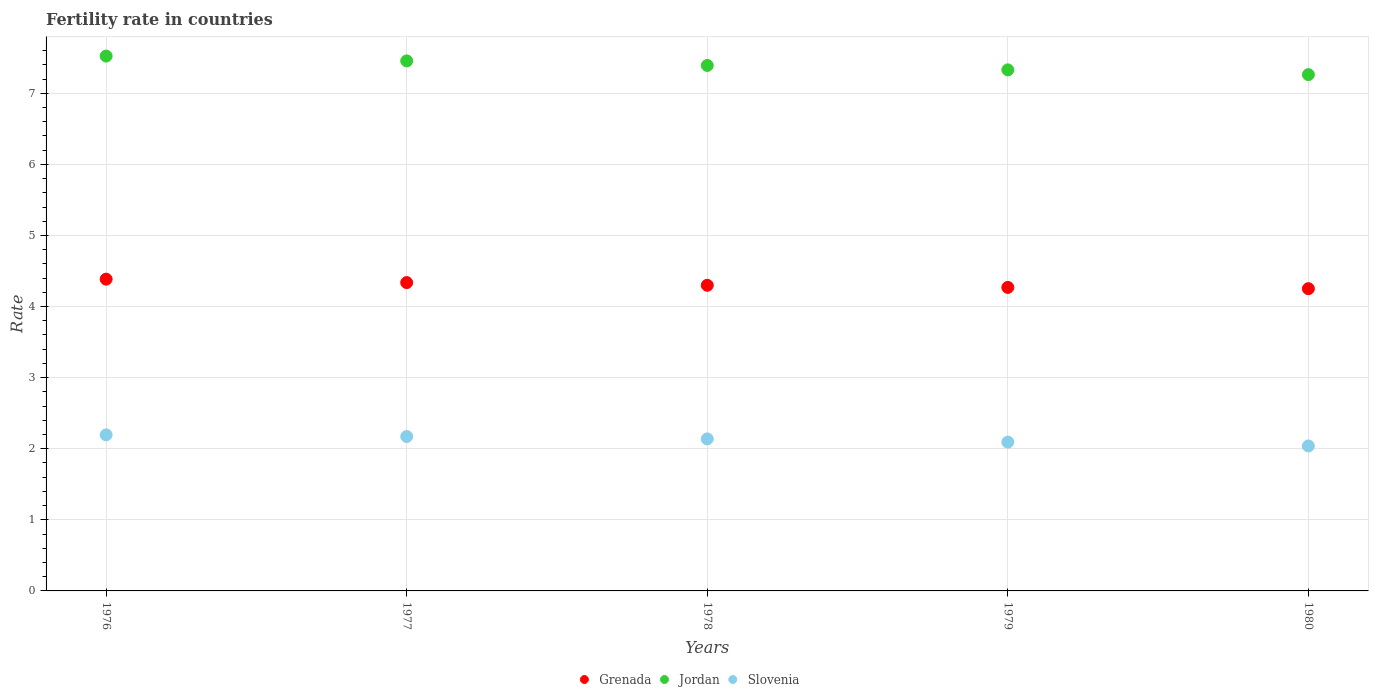How many different coloured dotlines are there?
Provide a succinct answer. 3. Is the number of dotlines equal to the number of legend labels?
Keep it short and to the point. Yes. What is the fertility rate in Grenada in 1977?
Your answer should be compact. 4.34. Across all years, what is the maximum fertility rate in Jordan?
Your answer should be very brief. 7.52. Across all years, what is the minimum fertility rate in Slovenia?
Offer a terse response. 2.04. In which year was the fertility rate in Grenada maximum?
Provide a short and direct response. 1976. In which year was the fertility rate in Grenada minimum?
Offer a terse response. 1980. What is the total fertility rate in Jordan in the graph?
Keep it short and to the point. 36.96. What is the difference between the fertility rate in Grenada in 1977 and that in 1980?
Your answer should be compact. 0.09. What is the difference between the fertility rate in Jordan in 1978 and the fertility rate in Slovenia in 1976?
Offer a terse response. 5.2. What is the average fertility rate in Jordan per year?
Provide a succinct answer. 7.39. In the year 1976, what is the difference between the fertility rate in Slovenia and fertility rate in Grenada?
Provide a short and direct response. -2.19. In how many years, is the fertility rate in Slovenia greater than 5?
Provide a succinct answer. 0. What is the ratio of the fertility rate in Slovenia in 1977 to that in 1980?
Provide a short and direct response. 1.07. Is the fertility rate in Jordan in 1979 less than that in 1980?
Your answer should be very brief. No. What is the difference between the highest and the second highest fertility rate in Grenada?
Your answer should be very brief. 0.05. What is the difference between the highest and the lowest fertility rate in Grenada?
Your answer should be compact. 0.13. In how many years, is the fertility rate in Slovenia greater than the average fertility rate in Slovenia taken over all years?
Offer a terse response. 3. Is it the case that in every year, the sum of the fertility rate in Jordan and fertility rate in Grenada  is greater than the fertility rate in Slovenia?
Your response must be concise. Yes. Is the fertility rate in Jordan strictly less than the fertility rate in Slovenia over the years?
Offer a very short reply. No. How many dotlines are there?
Provide a short and direct response. 3. What is the difference between two consecutive major ticks on the Y-axis?
Provide a short and direct response. 1. Does the graph contain any zero values?
Your answer should be very brief. No. Does the graph contain grids?
Keep it short and to the point. Yes. How are the legend labels stacked?
Provide a succinct answer. Horizontal. What is the title of the graph?
Your answer should be very brief. Fertility rate in countries. What is the label or title of the X-axis?
Your answer should be very brief. Years. What is the label or title of the Y-axis?
Offer a very short reply. Rate. What is the Rate of Grenada in 1976?
Your answer should be compact. 4.38. What is the Rate in Jordan in 1976?
Keep it short and to the point. 7.52. What is the Rate of Slovenia in 1976?
Your answer should be very brief. 2.19. What is the Rate in Grenada in 1977?
Ensure brevity in your answer.  4.34. What is the Rate of Jordan in 1977?
Ensure brevity in your answer.  7.46. What is the Rate in Slovenia in 1977?
Make the answer very short. 2.17. What is the Rate in Grenada in 1978?
Provide a short and direct response. 4.3. What is the Rate of Jordan in 1978?
Keep it short and to the point. 7.39. What is the Rate in Slovenia in 1978?
Your answer should be compact. 2.14. What is the Rate of Grenada in 1979?
Offer a very short reply. 4.27. What is the Rate of Jordan in 1979?
Give a very brief answer. 7.33. What is the Rate in Slovenia in 1979?
Offer a terse response. 2.09. What is the Rate in Grenada in 1980?
Your answer should be very brief. 4.25. What is the Rate in Jordan in 1980?
Give a very brief answer. 7.26. What is the Rate of Slovenia in 1980?
Keep it short and to the point. 2.04. Across all years, what is the maximum Rate of Grenada?
Your answer should be very brief. 4.38. Across all years, what is the maximum Rate in Jordan?
Make the answer very short. 7.52. Across all years, what is the maximum Rate in Slovenia?
Provide a short and direct response. 2.19. Across all years, what is the minimum Rate of Grenada?
Provide a succinct answer. 4.25. Across all years, what is the minimum Rate of Jordan?
Your answer should be very brief. 7.26. Across all years, what is the minimum Rate in Slovenia?
Your answer should be very brief. 2.04. What is the total Rate of Grenada in the graph?
Your answer should be compact. 21.54. What is the total Rate in Jordan in the graph?
Ensure brevity in your answer.  36.96. What is the total Rate in Slovenia in the graph?
Your response must be concise. 10.64. What is the difference between the Rate of Grenada in 1976 and that in 1977?
Provide a short and direct response. 0.05. What is the difference between the Rate in Jordan in 1976 and that in 1977?
Your answer should be compact. 0.07. What is the difference between the Rate of Slovenia in 1976 and that in 1977?
Your answer should be very brief. 0.02. What is the difference between the Rate in Grenada in 1976 and that in 1978?
Your answer should be very brief. 0.09. What is the difference between the Rate of Jordan in 1976 and that in 1978?
Give a very brief answer. 0.13. What is the difference between the Rate in Slovenia in 1976 and that in 1978?
Ensure brevity in your answer.  0.06. What is the difference between the Rate in Grenada in 1976 and that in 1979?
Your answer should be compact. 0.12. What is the difference between the Rate of Jordan in 1976 and that in 1979?
Offer a terse response. 0.19. What is the difference between the Rate in Slovenia in 1976 and that in 1979?
Keep it short and to the point. 0.1. What is the difference between the Rate of Grenada in 1976 and that in 1980?
Ensure brevity in your answer.  0.13. What is the difference between the Rate of Jordan in 1976 and that in 1980?
Give a very brief answer. 0.26. What is the difference between the Rate of Slovenia in 1976 and that in 1980?
Provide a succinct answer. 0.16. What is the difference between the Rate of Grenada in 1977 and that in 1978?
Your answer should be compact. 0.04. What is the difference between the Rate of Jordan in 1977 and that in 1978?
Ensure brevity in your answer.  0.06. What is the difference between the Rate in Slovenia in 1977 and that in 1978?
Your answer should be compact. 0.03. What is the difference between the Rate in Grenada in 1977 and that in 1979?
Ensure brevity in your answer.  0.07. What is the difference between the Rate of Jordan in 1977 and that in 1979?
Give a very brief answer. 0.13. What is the difference between the Rate of Slovenia in 1977 and that in 1979?
Ensure brevity in your answer.  0.08. What is the difference between the Rate of Grenada in 1977 and that in 1980?
Provide a succinct answer. 0.09. What is the difference between the Rate in Jordan in 1977 and that in 1980?
Your answer should be very brief. 0.19. What is the difference between the Rate of Slovenia in 1977 and that in 1980?
Offer a terse response. 0.13. What is the difference between the Rate in Jordan in 1978 and that in 1979?
Provide a succinct answer. 0.06. What is the difference between the Rate of Slovenia in 1978 and that in 1979?
Provide a short and direct response. 0.04. What is the difference between the Rate of Grenada in 1978 and that in 1980?
Ensure brevity in your answer.  0.05. What is the difference between the Rate in Jordan in 1978 and that in 1980?
Give a very brief answer. 0.13. What is the difference between the Rate of Slovenia in 1978 and that in 1980?
Keep it short and to the point. 0.1. What is the difference between the Rate in Grenada in 1979 and that in 1980?
Provide a short and direct response. 0.02. What is the difference between the Rate in Jordan in 1979 and that in 1980?
Offer a very short reply. 0.07. What is the difference between the Rate in Slovenia in 1979 and that in 1980?
Provide a succinct answer. 0.05. What is the difference between the Rate of Grenada in 1976 and the Rate of Jordan in 1977?
Your response must be concise. -3.07. What is the difference between the Rate of Grenada in 1976 and the Rate of Slovenia in 1977?
Make the answer very short. 2.21. What is the difference between the Rate of Jordan in 1976 and the Rate of Slovenia in 1977?
Offer a very short reply. 5.35. What is the difference between the Rate in Grenada in 1976 and the Rate in Jordan in 1978?
Give a very brief answer. -3.01. What is the difference between the Rate of Grenada in 1976 and the Rate of Slovenia in 1978?
Offer a very short reply. 2.25. What is the difference between the Rate in Jordan in 1976 and the Rate in Slovenia in 1978?
Offer a very short reply. 5.38. What is the difference between the Rate of Grenada in 1976 and the Rate of Jordan in 1979?
Your answer should be very brief. -2.94. What is the difference between the Rate of Grenada in 1976 and the Rate of Slovenia in 1979?
Keep it short and to the point. 2.29. What is the difference between the Rate in Jordan in 1976 and the Rate in Slovenia in 1979?
Give a very brief answer. 5.43. What is the difference between the Rate in Grenada in 1976 and the Rate in Jordan in 1980?
Your response must be concise. -2.88. What is the difference between the Rate in Grenada in 1976 and the Rate in Slovenia in 1980?
Give a very brief answer. 2.35. What is the difference between the Rate of Jordan in 1976 and the Rate of Slovenia in 1980?
Give a very brief answer. 5.48. What is the difference between the Rate of Grenada in 1977 and the Rate of Jordan in 1978?
Give a very brief answer. -3.05. What is the difference between the Rate in Grenada in 1977 and the Rate in Slovenia in 1978?
Make the answer very short. 2.2. What is the difference between the Rate in Jordan in 1977 and the Rate in Slovenia in 1978?
Offer a very short reply. 5.32. What is the difference between the Rate in Grenada in 1977 and the Rate in Jordan in 1979?
Give a very brief answer. -2.99. What is the difference between the Rate in Grenada in 1977 and the Rate in Slovenia in 1979?
Provide a short and direct response. 2.24. What is the difference between the Rate in Jordan in 1977 and the Rate in Slovenia in 1979?
Your answer should be very brief. 5.36. What is the difference between the Rate in Grenada in 1977 and the Rate in Jordan in 1980?
Your answer should be very brief. -2.92. What is the difference between the Rate of Grenada in 1977 and the Rate of Slovenia in 1980?
Provide a short and direct response. 2.3. What is the difference between the Rate in Jordan in 1977 and the Rate in Slovenia in 1980?
Offer a very short reply. 5.42. What is the difference between the Rate in Grenada in 1978 and the Rate in Jordan in 1979?
Your response must be concise. -3.03. What is the difference between the Rate in Grenada in 1978 and the Rate in Slovenia in 1979?
Your answer should be very brief. 2.21. What is the difference between the Rate in Jordan in 1978 and the Rate in Slovenia in 1979?
Ensure brevity in your answer.  5.3. What is the difference between the Rate of Grenada in 1978 and the Rate of Jordan in 1980?
Your answer should be very brief. -2.96. What is the difference between the Rate of Grenada in 1978 and the Rate of Slovenia in 1980?
Keep it short and to the point. 2.26. What is the difference between the Rate in Jordan in 1978 and the Rate in Slovenia in 1980?
Keep it short and to the point. 5.35. What is the difference between the Rate in Grenada in 1979 and the Rate in Jordan in 1980?
Give a very brief answer. -2.99. What is the difference between the Rate of Grenada in 1979 and the Rate of Slovenia in 1980?
Keep it short and to the point. 2.23. What is the difference between the Rate of Jordan in 1979 and the Rate of Slovenia in 1980?
Provide a short and direct response. 5.29. What is the average Rate in Grenada per year?
Your answer should be compact. 4.31. What is the average Rate in Jordan per year?
Offer a terse response. 7.39. What is the average Rate of Slovenia per year?
Your answer should be compact. 2.13. In the year 1976, what is the difference between the Rate of Grenada and Rate of Jordan?
Make the answer very short. -3.14. In the year 1976, what is the difference between the Rate of Grenada and Rate of Slovenia?
Your answer should be very brief. 2.19. In the year 1976, what is the difference between the Rate in Jordan and Rate in Slovenia?
Make the answer very short. 5.33. In the year 1977, what is the difference between the Rate of Grenada and Rate of Jordan?
Your response must be concise. -3.12. In the year 1977, what is the difference between the Rate in Grenada and Rate in Slovenia?
Offer a terse response. 2.17. In the year 1977, what is the difference between the Rate of Jordan and Rate of Slovenia?
Provide a short and direct response. 5.28. In the year 1978, what is the difference between the Rate of Grenada and Rate of Jordan?
Offer a very short reply. -3.09. In the year 1978, what is the difference between the Rate of Grenada and Rate of Slovenia?
Make the answer very short. 2.16. In the year 1978, what is the difference between the Rate in Jordan and Rate in Slovenia?
Ensure brevity in your answer.  5.25. In the year 1979, what is the difference between the Rate in Grenada and Rate in Jordan?
Your answer should be very brief. -3.06. In the year 1979, what is the difference between the Rate in Grenada and Rate in Slovenia?
Your answer should be compact. 2.18. In the year 1979, what is the difference between the Rate in Jordan and Rate in Slovenia?
Offer a very short reply. 5.24. In the year 1980, what is the difference between the Rate of Grenada and Rate of Jordan?
Offer a terse response. -3.01. In the year 1980, what is the difference between the Rate in Grenada and Rate in Slovenia?
Make the answer very short. 2.21. In the year 1980, what is the difference between the Rate of Jordan and Rate of Slovenia?
Keep it short and to the point. 5.22. What is the ratio of the Rate in Grenada in 1976 to that in 1977?
Give a very brief answer. 1.01. What is the ratio of the Rate in Jordan in 1976 to that in 1977?
Ensure brevity in your answer.  1.01. What is the ratio of the Rate of Slovenia in 1976 to that in 1977?
Your answer should be very brief. 1.01. What is the ratio of the Rate of Grenada in 1976 to that in 1978?
Offer a terse response. 1.02. What is the ratio of the Rate in Jordan in 1976 to that in 1978?
Offer a very short reply. 1.02. What is the ratio of the Rate of Slovenia in 1976 to that in 1978?
Give a very brief answer. 1.03. What is the ratio of the Rate of Grenada in 1976 to that in 1979?
Provide a short and direct response. 1.03. What is the ratio of the Rate of Jordan in 1976 to that in 1979?
Provide a short and direct response. 1.03. What is the ratio of the Rate in Slovenia in 1976 to that in 1979?
Offer a terse response. 1.05. What is the ratio of the Rate in Grenada in 1976 to that in 1980?
Provide a succinct answer. 1.03. What is the ratio of the Rate of Jordan in 1976 to that in 1980?
Offer a very short reply. 1.04. What is the ratio of the Rate of Slovenia in 1976 to that in 1980?
Provide a succinct answer. 1.08. What is the ratio of the Rate of Grenada in 1977 to that in 1978?
Give a very brief answer. 1.01. What is the ratio of the Rate in Jordan in 1977 to that in 1978?
Keep it short and to the point. 1.01. What is the ratio of the Rate of Slovenia in 1977 to that in 1978?
Give a very brief answer. 1.02. What is the ratio of the Rate of Grenada in 1977 to that in 1979?
Provide a succinct answer. 1.02. What is the ratio of the Rate of Jordan in 1977 to that in 1979?
Give a very brief answer. 1.02. What is the ratio of the Rate of Slovenia in 1977 to that in 1979?
Make the answer very short. 1.04. What is the ratio of the Rate in Grenada in 1977 to that in 1980?
Keep it short and to the point. 1.02. What is the ratio of the Rate in Jordan in 1977 to that in 1980?
Your response must be concise. 1.03. What is the ratio of the Rate in Slovenia in 1977 to that in 1980?
Offer a terse response. 1.07. What is the ratio of the Rate in Grenada in 1978 to that in 1979?
Make the answer very short. 1.01. What is the ratio of the Rate of Jordan in 1978 to that in 1979?
Make the answer very short. 1.01. What is the ratio of the Rate in Slovenia in 1978 to that in 1979?
Provide a succinct answer. 1.02. What is the ratio of the Rate in Grenada in 1978 to that in 1980?
Ensure brevity in your answer.  1.01. What is the ratio of the Rate in Jordan in 1978 to that in 1980?
Offer a very short reply. 1.02. What is the ratio of the Rate in Slovenia in 1978 to that in 1980?
Offer a very short reply. 1.05. What is the ratio of the Rate in Jordan in 1979 to that in 1980?
Offer a terse response. 1.01. What is the ratio of the Rate in Slovenia in 1979 to that in 1980?
Keep it short and to the point. 1.03. What is the difference between the highest and the second highest Rate in Grenada?
Your answer should be very brief. 0.05. What is the difference between the highest and the second highest Rate of Jordan?
Keep it short and to the point. 0.07. What is the difference between the highest and the second highest Rate in Slovenia?
Your answer should be very brief. 0.02. What is the difference between the highest and the lowest Rate in Grenada?
Your answer should be very brief. 0.13. What is the difference between the highest and the lowest Rate in Jordan?
Ensure brevity in your answer.  0.26. What is the difference between the highest and the lowest Rate of Slovenia?
Give a very brief answer. 0.16. 